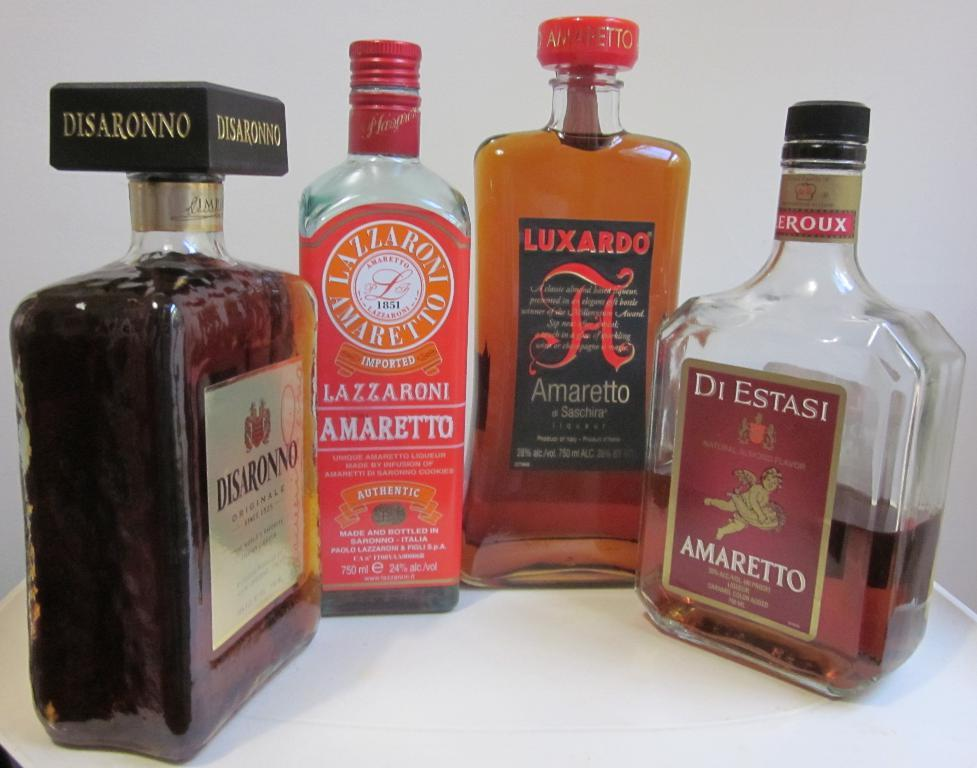<image>
Offer a succinct explanation of the picture presented. Four different brands of amaretto are arranged together in a semi-circle. 